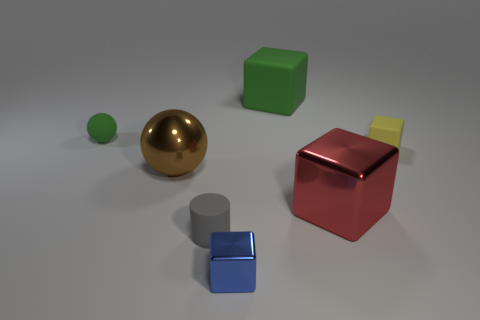Subtract all balls. How many objects are left? 5 Subtract 1 blocks. How many blocks are left? 3 Subtract all green spheres. Subtract all purple cylinders. How many spheres are left? 1 Subtract all yellow balls. How many blue cubes are left? 1 Subtract all green balls. Subtract all large rubber blocks. How many objects are left? 5 Add 7 tiny yellow objects. How many tiny yellow objects are left? 8 Add 2 large brown balls. How many large brown balls exist? 3 Add 1 green metal blocks. How many objects exist? 8 Subtract all blue cubes. How many cubes are left? 3 Subtract all yellow rubber blocks. How many blocks are left? 3 